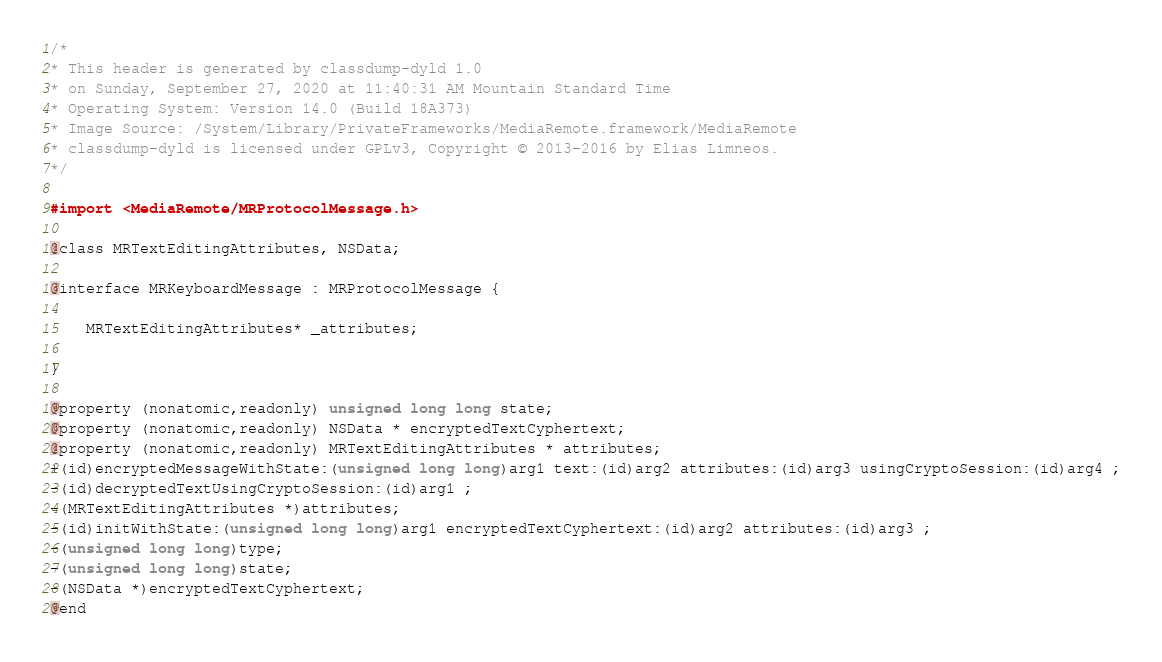Convert code to text. <code><loc_0><loc_0><loc_500><loc_500><_C_>/*
* This header is generated by classdump-dyld 1.0
* on Sunday, September 27, 2020 at 11:40:31 AM Mountain Standard Time
* Operating System: Version 14.0 (Build 18A373)
* Image Source: /System/Library/PrivateFrameworks/MediaRemote.framework/MediaRemote
* classdump-dyld is licensed under GPLv3, Copyright © 2013-2016 by Elias Limneos.
*/

#import <MediaRemote/MRProtocolMessage.h>

@class MRTextEditingAttributes, NSData;

@interface MRKeyboardMessage : MRProtocolMessage {

	MRTextEditingAttributes* _attributes;

}

@property (nonatomic,readonly) unsigned long long state; 
@property (nonatomic,readonly) NSData * encryptedTextCyphertext; 
@property (nonatomic,readonly) MRTextEditingAttributes * attributes; 
+(id)encryptedMessageWithState:(unsigned long long)arg1 text:(id)arg2 attributes:(id)arg3 usingCryptoSession:(id)arg4 ;
-(id)decryptedTextUsingCryptoSession:(id)arg1 ;
-(MRTextEditingAttributes *)attributes;
-(id)initWithState:(unsigned long long)arg1 encryptedTextCyphertext:(id)arg2 attributes:(id)arg3 ;
-(unsigned long long)type;
-(unsigned long long)state;
-(NSData *)encryptedTextCyphertext;
@end

</code> 